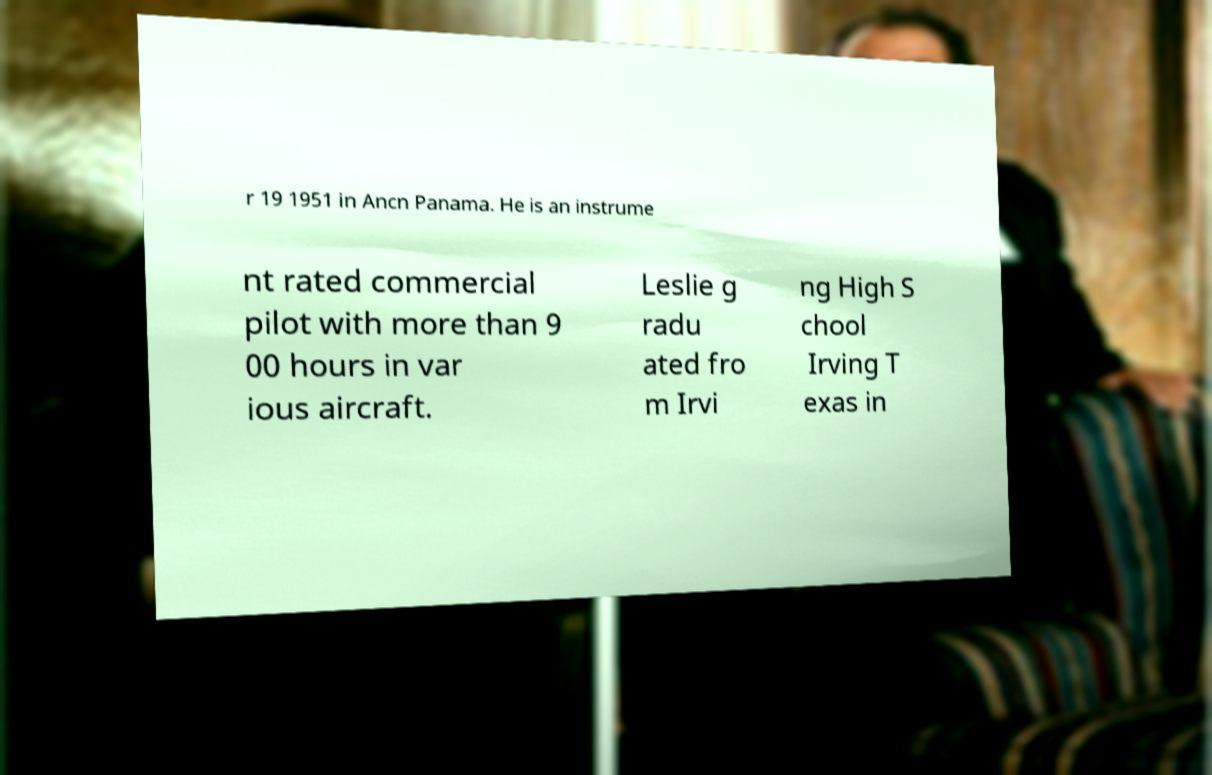Could you assist in decoding the text presented in this image and type it out clearly? r 19 1951 in Ancn Panama. He is an instrume nt rated commercial pilot with more than 9 00 hours in var ious aircraft. Leslie g radu ated fro m Irvi ng High S chool Irving T exas in 